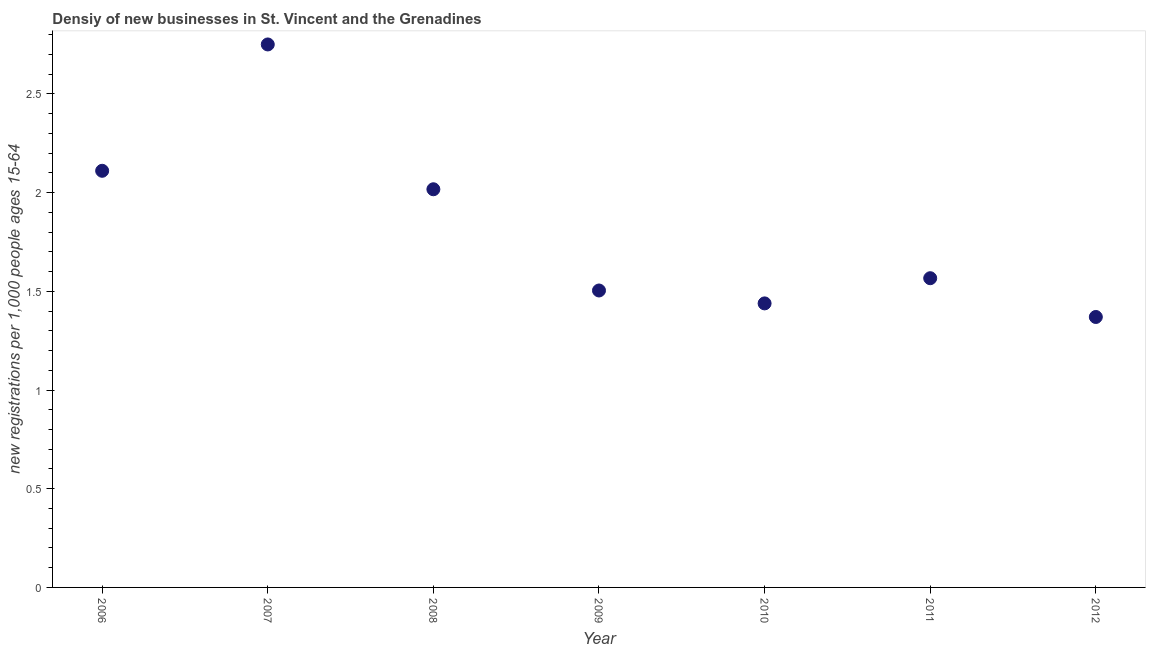What is the density of new business in 2009?
Offer a very short reply. 1.5. Across all years, what is the maximum density of new business?
Offer a terse response. 2.75. Across all years, what is the minimum density of new business?
Your answer should be compact. 1.37. What is the sum of the density of new business?
Your answer should be very brief. 12.76. What is the difference between the density of new business in 2008 and 2010?
Ensure brevity in your answer.  0.58. What is the average density of new business per year?
Keep it short and to the point. 1.82. What is the median density of new business?
Ensure brevity in your answer.  1.57. In how many years, is the density of new business greater than 1.6 ?
Your answer should be compact. 3. Do a majority of the years between 2012 and 2008 (inclusive) have density of new business greater than 1.6 ?
Your answer should be very brief. Yes. What is the ratio of the density of new business in 2010 to that in 2012?
Provide a short and direct response. 1.05. Is the difference between the density of new business in 2008 and 2010 greater than the difference between any two years?
Your answer should be compact. No. What is the difference between the highest and the second highest density of new business?
Offer a terse response. 0.64. What is the difference between the highest and the lowest density of new business?
Your answer should be very brief. 1.38. Does the density of new business monotonically increase over the years?
Give a very brief answer. No. What is the difference between two consecutive major ticks on the Y-axis?
Your answer should be compact. 0.5. Are the values on the major ticks of Y-axis written in scientific E-notation?
Offer a very short reply. No. Does the graph contain any zero values?
Your answer should be compact. No. What is the title of the graph?
Ensure brevity in your answer.  Densiy of new businesses in St. Vincent and the Grenadines. What is the label or title of the Y-axis?
Offer a very short reply. New registrations per 1,0 people ages 15-64. What is the new registrations per 1,000 people ages 15-64 in 2006?
Offer a terse response. 2.11. What is the new registrations per 1,000 people ages 15-64 in 2007?
Provide a short and direct response. 2.75. What is the new registrations per 1,000 people ages 15-64 in 2008?
Offer a very short reply. 2.02. What is the new registrations per 1,000 people ages 15-64 in 2009?
Your response must be concise. 1.5. What is the new registrations per 1,000 people ages 15-64 in 2010?
Give a very brief answer. 1.44. What is the new registrations per 1,000 people ages 15-64 in 2011?
Offer a very short reply. 1.57. What is the new registrations per 1,000 people ages 15-64 in 2012?
Your answer should be compact. 1.37. What is the difference between the new registrations per 1,000 people ages 15-64 in 2006 and 2007?
Your response must be concise. -0.64. What is the difference between the new registrations per 1,000 people ages 15-64 in 2006 and 2008?
Offer a terse response. 0.09. What is the difference between the new registrations per 1,000 people ages 15-64 in 2006 and 2009?
Your answer should be compact. 0.61. What is the difference between the new registrations per 1,000 people ages 15-64 in 2006 and 2010?
Your answer should be compact. 0.67. What is the difference between the new registrations per 1,000 people ages 15-64 in 2006 and 2011?
Your answer should be compact. 0.54. What is the difference between the new registrations per 1,000 people ages 15-64 in 2006 and 2012?
Provide a short and direct response. 0.74. What is the difference between the new registrations per 1,000 people ages 15-64 in 2007 and 2008?
Provide a short and direct response. 0.73. What is the difference between the new registrations per 1,000 people ages 15-64 in 2007 and 2009?
Your answer should be very brief. 1.25. What is the difference between the new registrations per 1,000 people ages 15-64 in 2007 and 2010?
Offer a terse response. 1.31. What is the difference between the new registrations per 1,000 people ages 15-64 in 2007 and 2011?
Make the answer very short. 1.18. What is the difference between the new registrations per 1,000 people ages 15-64 in 2007 and 2012?
Give a very brief answer. 1.38. What is the difference between the new registrations per 1,000 people ages 15-64 in 2008 and 2009?
Give a very brief answer. 0.51. What is the difference between the new registrations per 1,000 people ages 15-64 in 2008 and 2010?
Provide a succinct answer. 0.58. What is the difference between the new registrations per 1,000 people ages 15-64 in 2008 and 2011?
Ensure brevity in your answer.  0.45. What is the difference between the new registrations per 1,000 people ages 15-64 in 2008 and 2012?
Provide a succinct answer. 0.65. What is the difference between the new registrations per 1,000 people ages 15-64 in 2009 and 2010?
Give a very brief answer. 0.07. What is the difference between the new registrations per 1,000 people ages 15-64 in 2009 and 2011?
Offer a very short reply. -0.06. What is the difference between the new registrations per 1,000 people ages 15-64 in 2009 and 2012?
Provide a short and direct response. 0.13. What is the difference between the new registrations per 1,000 people ages 15-64 in 2010 and 2011?
Your response must be concise. -0.13. What is the difference between the new registrations per 1,000 people ages 15-64 in 2010 and 2012?
Your answer should be very brief. 0.07. What is the difference between the new registrations per 1,000 people ages 15-64 in 2011 and 2012?
Ensure brevity in your answer.  0.2. What is the ratio of the new registrations per 1,000 people ages 15-64 in 2006 to that in 2007?
Make the answer very short. 0.77. What is the ratio of the new registrations per 1,000 people ages 15-64 in 2006 to that in 2008?
Provide a succinct answer. 1.05. What is the ratio of the new registrations per 1,000 people ages 15-64 in 2006 to that in 2009?
Offer a very short reply. 1.4. What is the ratio of the new registrations per 1,000 people ages 15-64 in 2006 to that in 2010?
Keep it short and to the point. 1.47. What is the ratio of the new registrations per 1,000 people ages 15-64 in 2006 to that in 2011?
Keep it short and to the point. 1.35. What is the ratio of the new registrations per 1,000 people ages 15-64 in 2006 to that in 2012?
Give a very brief answer. 1.54. What is the ratio of the new registrations per 1,000 people ages 15-64 in 2007 to that in 2008?
Provide a short and direct response. 1.36. What is the ratio of the new registrations per 1,000 people ages 15-64 in 2007 to that in 2009?
Keep it short and to the point. 1.83. What is the ratio of the new registrations per 1,000 people ages 15-64 in 2007 to that in 2010?
Keep it short and to the point. 1.91. What is the ratio of the new registrations per 1,000 people ages 15-64 in 2007 to that in 2011?
Offer a terse response. 1.76. What is the ratio of the new registrations per 1,000 people ages 15-64 in 2007 to that in 2012?
Offer a very short reply. 2.01. What is the ratio of the new registrations per 1,000 people ages 15-64 in 2008 to that in 2009?
Provide a short and direct response. 1.34. What is the ratio of the new registrations per 1,000 people ages 15-64 in 2008 to that in 2010?
Keep it short and to the point. 1.4. What is the ratio of the new registrations per 1,000 people ages 15-64 in 2008 to that in 2011?
Provide a succinct answer. 1.29. What is the ratio of the new registrations per 1,000 people ages 15-64 in 2008 to that in 2012?
Ensure brevity in your answer.  1.47. What is the ratio of the new registrations per 1,000 people ages 15-64 in 2009 to that in 2010?
Offer a terse response. 1.04. What is the ratio of the new registrations per 1,000 people ages 15-64 in 2009 to that in 2011?
Offer a very short reply. 0.96. What is the ratio of the new registrations per 1,000 people ages 15-64 in 2009 to that in 2012?
Provide a succinct answer. 1.1. What is the ratio of the new registrations per 1,000 people ages 15-64 in 2010 to that in 2011?
Your answer should be compact. 0.92. What is the ratio of the new registrations per 1,000 people ages 15-64 in 2011 to that in 2012?
Offer a very short reply. 1.14. 